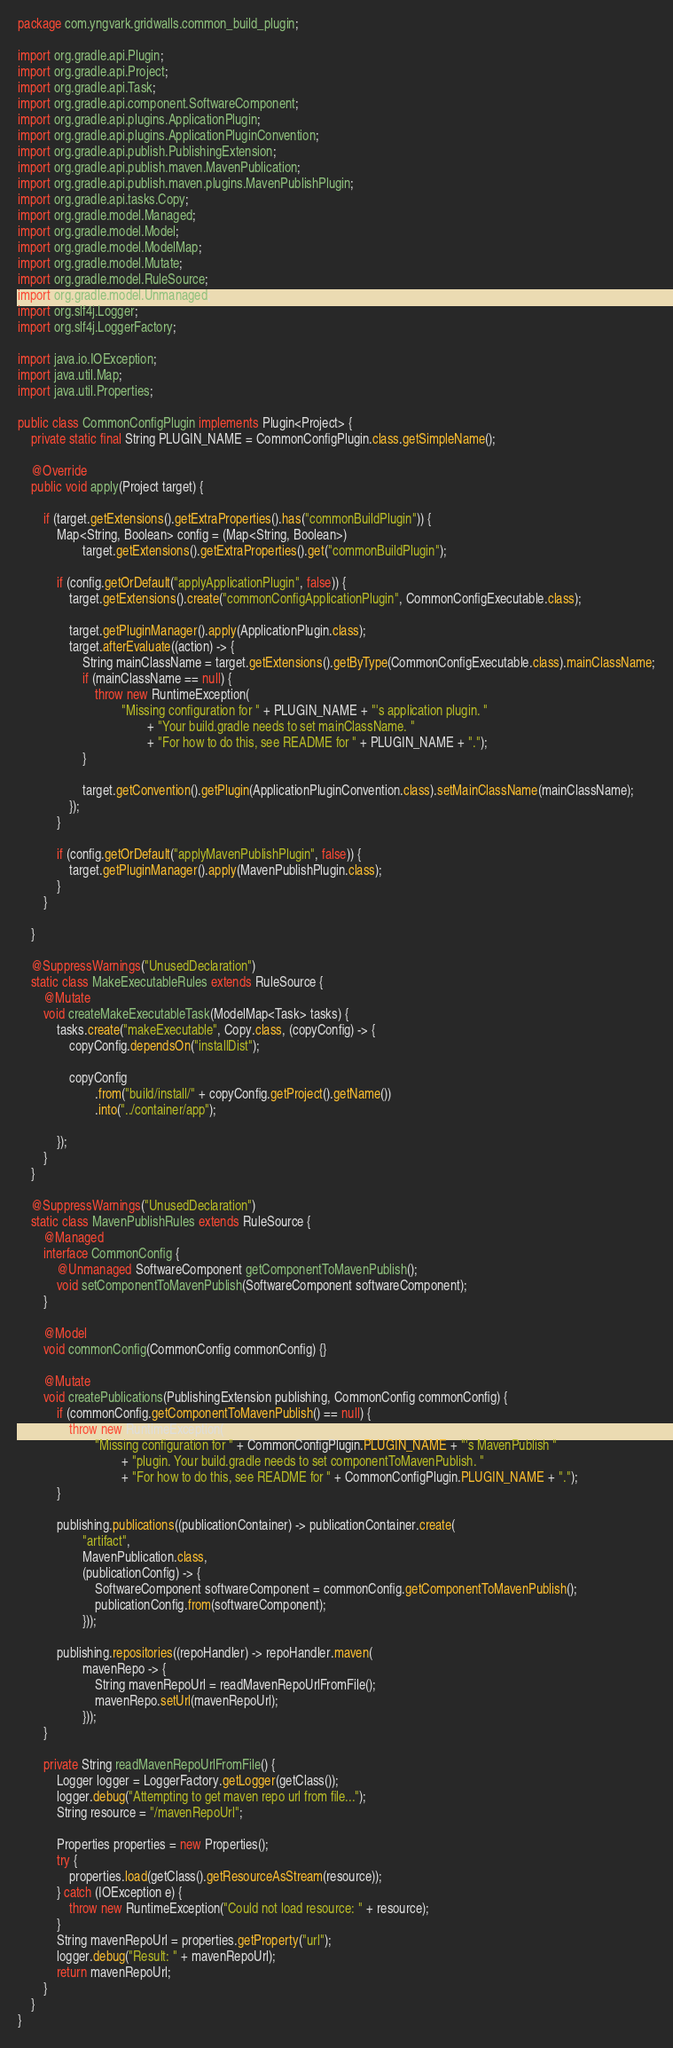<code> <loc_0><loc_0><loc_500><loc_500><_Java_>package com.yngvark.gridwalls.common_build_plugin;

import org.gradle.api.Plugin;
import org.gradle.api.Project;
import org.gradle.api.Task;
import org.gradle.api.component.SoftwareComponent;
import org.gradle.api.plugins.ApplicationPlugin;
import org.gradle.api.plugins.ApplicationPluginConvention;
import org.gradle.api.publish.PublishingExtension;
import org.gradle.api.publish.maven.MavenPublication;
import org.gradle.api.publish.maven.plugins.MavenPublishPlugin;
import org.gradle.api.tasks.Copy;
import org.gradle.model.Managed;
import org.gradle.model.Model;
import org.gradle.model.ModelMap;
import org.gradle.model.Mutate;
import org.gradle.model.RuleSource;
import org.gradle.model.Unmanaged;
import org.slf4j.Logger;
import org.slf4j.LoggerFactory;

import java.io.IOException;
import java.util.Map;
import java.util.Properties;

public class CommonConfigPlugin implements Plugin<Project> {
    private static final String PLUGIN_NAME = CommonConfigPlugin.class.getSimpleName();

    @Override
    public void apply(Project target) {

        if (target.getExtensions().getExtraProperties().has("commonBuildPlugin")) {
            Map<String, Boolean> config = (Map<String, Boolean>)
                    target.getExtensions().getExtraProperties().get("commonBuildPlugin");

            if (config.getOrDefault("applyApplicationPlugin", false)) {
                target.getExtensions().create("commonConfigApplicationPlugin", CommonConfigExecutable.class);

                target.getPluginManager().apply(ApplicationPlugin.class);
                target.afterEvaluate((action) -> {
                    String mainClassName = target.getExtensions().getByType(CommonConfigExecutable.class).mainClassName;
                    if (mainClassName == null) {
                        throw new RuntimeException(
                                "Missing configuration for " + PLUGIN_NAME + "'s application plugin. "
                                        + "Your build.gradle needs to set mainClassName. "
                                        + "For how to do this, see README for " + PLUGIN_NAME + ".");
                    }

                    target.getConvention().getPlugin(ApplicationPluginConvention.class).setMainClassName(mainClassName);
                });
            }

            if (config.getOrDefault("applyMavenPublishPlugin", false)) {
                target.getPluginManager().apply(MavenPublishPlugin.class);
            }
        }

    }

    @SuppressWarnings("UnusedDeclaration")
    static class MakeExecutableRules extends RuleSource {
        @Mutate
        void createMakeExecutableTask(ModelMap<Task> tasks) {
            tasks.create("makeExecutable", Copy.class, (copyConfig) -> {
                copyConfig.dependsOn("installDist");

                copyConfig
                        .from("build/install/" + copyConfig.getProject().getName())
                        .into("../container/app");

            });
        }
    }

    @SuppressWarnings("UnusedDeclaration")
    static class MavenPublishRules extends RuleSource {
        @Managed
        interface CommonConfig {
            @Unmanaged SoftwareComponent getComponentToMavenPublish();
            void setComponentToMavenPublish(SoftwareComponent softwareComponent);
        }

        @Model
        void commonConfig(CommonConfig commonConfig) {}

        @Mutate
        void createPublications(PublishingExtension publishing, CommonConfig commonConfig) {
            if (commonConfig.getComponentToMavenPublish() == null) {
                throw new RuntimeException(
                        "Missing configuration for " + CommonConfigPlugin.PLUGIN_NAME + "'s MavenPublish "
                                + "plugin. Your build.gradle needs to set componentToMavenPublish. "
                                + "For how to do this, see README for " + CommonConfigPlugin.PLUGIN_NAME + ".");
            }

            publishing.publications((publicationContainer) -> publicationContainer.create(
                    "artifact",
                    MavenPublication.class,
                    (publicationConfig) -> {
                        SoftwareComponent softwareComponent = commonConfig.getComponentToMavenPublish();
                        publicationConfig.from(softwareComponent);
                    }));

            publishing.repositories((repoHandler) -> repoHandler.maven(
                    mavenRepo -> {
                        String mavenRepoUrl = readMavenRepoUrlFromFile();
                        mavenRepo.setUrl(mavenRepoUrl);
                    }));
        }

        private String readMavenRepoUrlFromFile() {
            Logger logger = LoggerFactory.getLogger(getClass());
            logger.debug("Attempting to get maven repo url from file...");
            String resource = "/mavenRepoUrl";

            Properties properties = new Properties();
            try {
                properties.load(getClass().getResourceAsStream(resource));
            } catch (IOException e) {
                throw new RuntimeException("Could not load resource: " + resource);
            }
            String mavenRepoUrl = properties.getProperty("url");
            logger.debug("Result: " + mavenRepoUrl);
            return mavenRepoUrl;
        }
    }
}

</code> 